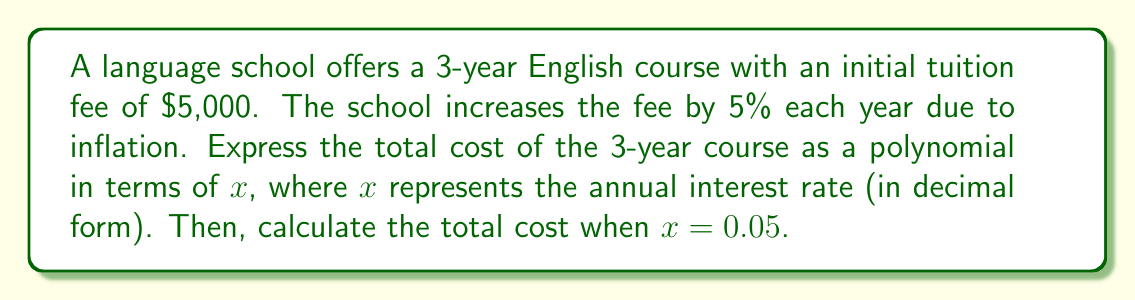Help me with this question. Let's approach this step-by-step:

1) First, let's express each year's tuition as a term in our polynomial:

   Year 1: $5000$
   Year 2: $5000(1+x)$
   Year 3: $5000(1+x)^2$

2) The total cost is the sum of these three terms:

   $T(x) = 5000 + 5000(1+x) + 5000(1+x)^2$

3) Let's expand this polynomial:

   $T(x) = 5000 + 5000 + 5000x + 5000 + 10000x + 5000x^2$

4) Simplifying:

   $T(x) = 15000 + 15000x + 5000x^2$

5) This is our final polynomial expression for the total cost.

6) To calculate the total cost when $x = 0.05$, we substitute this value:

   $T(0.05) = 15000 + 15000(0.05) + 5000(0.05)^2$

7) Let's calculate each term:

   $15000 = 15000$
   $15000(0.05) = 750$
   $5000(0.05)^2 = 5000(0.0025) = 12.5$

8) Sum these values:

   $15000 + 750 + 12.5 = 15762.5$
Answer: The total cost as a polynomial: $T(x) = 15000 + 15000x + 5000x^2$

The total cost when $x = 0.05$: $15762.50 